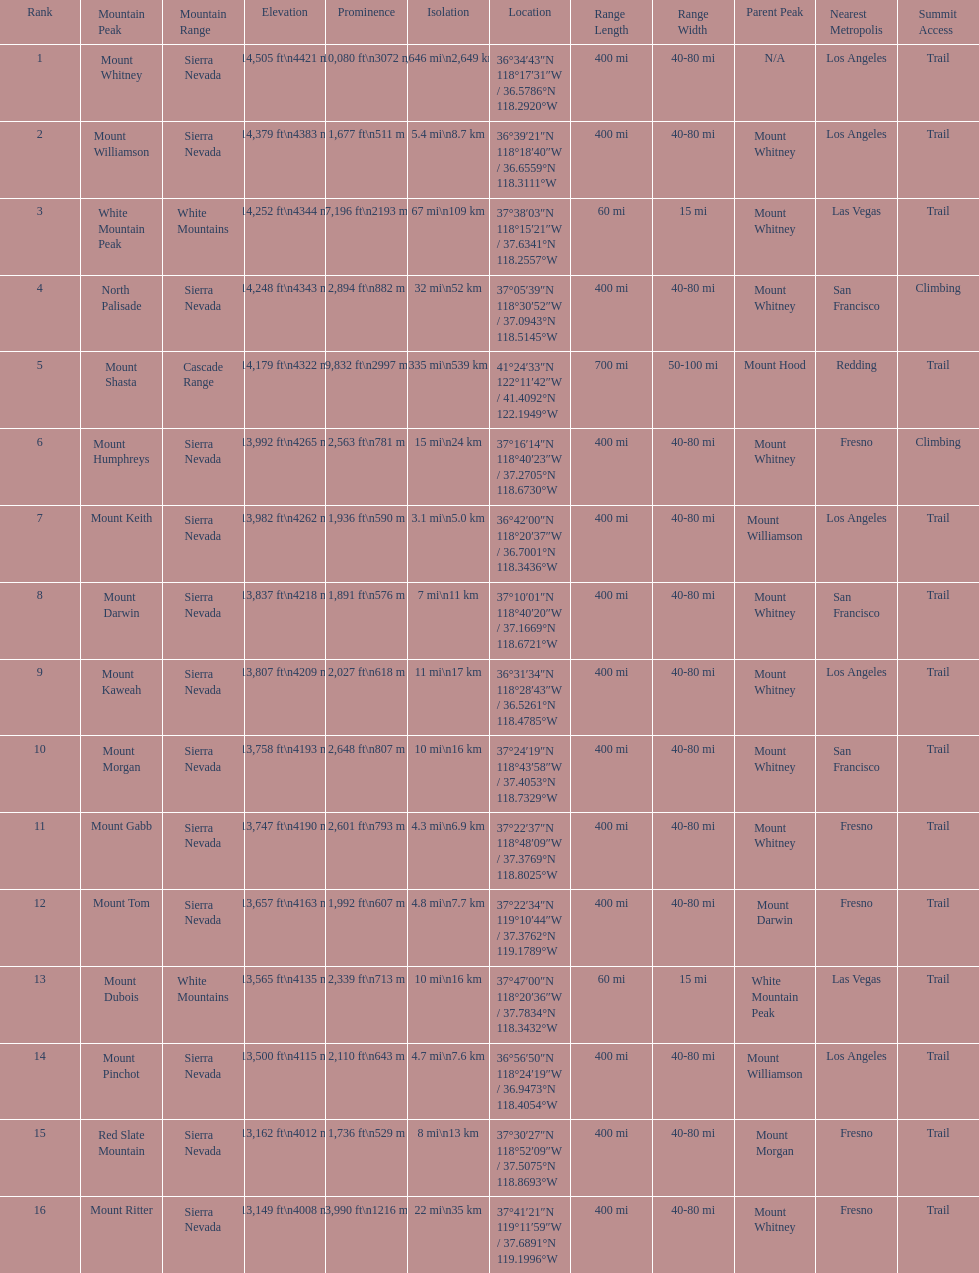Which mountain peak is no higher than 13,149 ft? Mount Ritter. 